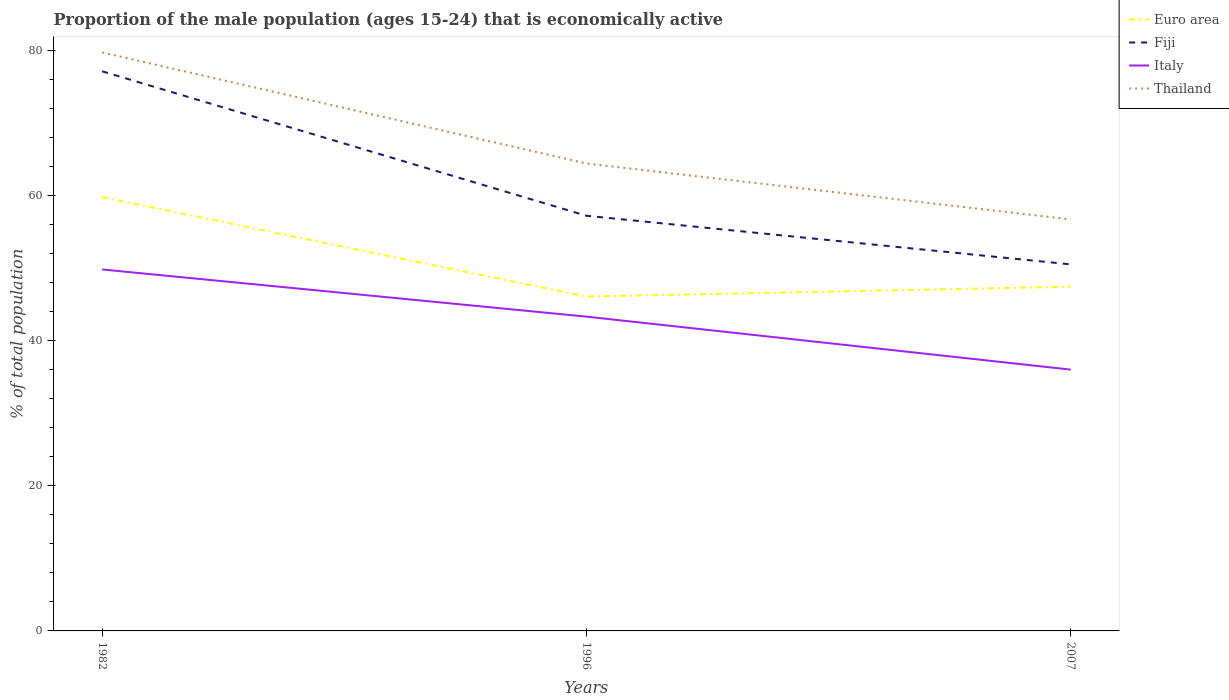How many different coloured lines are there?
Ensure brevity in your answer.  4. Does the line corresponding to Thailand intersect with the line corresponding to Fiji?
Offer a very short reply. No. Is the number of lines equal to the number of legend labels?
Your response must be concise. Yes. Across all years, what is the maximum proportion of the male population that is economically active in Euro area?
Your response must be concise. 46.06. In which year was the proportion of the male population that is economically active in Euro area maximum?
Keep it short and to the point. 1996. What is the total proportion of the male population that is economically active in Thailand in the graph?
Keep it short and to the point. 15.3. What is the difference between the highest and the second highest proportion of the male population that is economically active in Fiji?
Give a very brief answer. 26.6. What is the difference between the highest and the lowest proportion of the male population that is economically active in Italy?
Your response must be concise. 2. How many lines are there?
Your answer should be very brief. 4. What is the difference between two consecutive major ticks on the Y-axis?
Give a very brief answer. 20. Are the values on the major ticks of Y-axis written in scientific E-notation?
Your answer should be compact. No. Does the graph contain grids?
Provide a succinct answer. No. How many legend labels are there?
Ensure brevity in your answer.  4. How are the legend labels stacked?
Provide a succinct answer. Vertical. What is the title of the graph?
Offer a terse response. Proportion of the male population (ages 15-24) that is economically active. What is the label or title of the Y-axis?
Offer a terse response. % of total population. What is the % of total population of Euro area in 1982?
Make the answer very short. 59.76. What is the % of total population in Fiji in 1982?
Provide a succinct answer. 77.1. What is the % of total population in Italy in 1982?
Provide a succinct answer. 49.8. What is the % of total population in Thailand in 1982?
Provide a short and direct response. 79.7. What is the % of total population of Euro area in 1996?
Provide a succinct answer. 46.06. What is the % of total population of Fiji in 1996?
Offer a terse response. 57.2. What is the % of total population of Italy in 1996?
Your answer should be compact. 43.3. What is the % of total population of Thailand in 1996?
Your answer should be compact. 64.4. What is the % of total population in Euro area in 2007?
Make the answer very short. 47.43. What is the % of total population of Fiji in 2007?
Your response must be concise. 50.5. What is the % of total population in Italy in 2007?
Make the answer very short. 36. What is the % of total population of Thailand in 2007?
Offer a very short reply. 56.7. Across all years, what is the maximum % of total population of Euro area?
Keep it short and to the point. 59.76. Across all years, what is the maximum % of total population in Fiji?
Your answer should be compact. 77.1. Across all years, what is the maximum % of total population in Italy?
Provide a short and direct response. 49.8. Across all years, what is the maximum % of total population of Thailand?
Make the answer very short. 79.7. Across all years, what is the minimum % of total population in Euro area?
Make the answer very short. 46.06. Across all years, what is the minimum % of total population of Fiji?
Your response must be concise. 50.5. Across all years, what is the minimum % of total population of Italy?
Your answer should be compact. 36. Across all years, what is the minimum % of total population in Thailand?
Provide a succinct answer. 56.7. What is the total % of total population of Euro area in the graph?
Your response must be concise. 153.25. What is the total % of total population in Fiji in the graph?
Provide a short and direct response. 184.8. What is the total % of total population of Italy in the graph?
Ensure brevity in your answer.  129.1. What is the total % of total population of Thailand in the graph?
Ensure brevity in your answer.  200.8. What is the difference between the % of total population of Euro area in 1982 and that in 1996?
Provide a short and direct response. 13.69. What is the difference between the % of total population in Fiji in 1982 and that in 1996?
Offer a terse response. 19.9. What is the difference between the % of total population in Italy in 1982 and that in 1996?
Ensure brevity in your answer.  6.5. What is the difference between the % of total population of Euro area in 1982 and that in 2007?
Your answer should be compact. 12.33. What is the difference between the % of total population in Fiji in 1982 and that in 2007?
Give a very brief answer. 26.6. What is the difference between the % of total population of Italy in 1982 and that in 2007?
Give a very brief answer. 13.8. What is the difference between the % of total population of Thailand in 1982 and that in 2007?
Your answer should be very brief. 23. What is the difference between the % of total population in Euro area in 1996 and that in 2007?
Ensure brevity in your answer.  -1.37. What is the difference between the % of total population of Fiji in 1996 and that in 2007?
Provide a short and direct response. 6.7. What is the difference between the % of total population in Italy in 1996 and that in 2007?
Your response must be concise. 7.3. What is the difference between the % of total population in Thailand in 1996 and that in 2007?
Ensure brevity in your answer.  7.7. What is the difference between the % of total population of Euro area in 1982 and the % of total population of Fiji in 1996?
Your answer should be compact. 2.56. What is the difference between the % of total population of Euro area in 1982 and the % of total population of Italy in 1996?
Your answer should be very brief. 16.46. What is the difference between the % of total population of Euro area in 1982 and the % of total population of Thailand in 1996?
Your answer should be very brief. -4.64. What is the difference between the % of total population of Fiji in 1982 and the % of total population of Italy in 1996?
Provide a succinct answer. 33.8. What is the difference between the % of total population of Fiji in 1982 and the % of total population of Thailand in 1996?
Ensure brevity in your answer.  12.7. What is the difference between the % of total population of Italy in 1982 and the % of total population of Thailand in 1996?
Your response must be concise. -14.6. What is the difference between the % of total population of Euro area in 1982 and the % of total population of Fiji in 2007?
Ensure brevity in your answer.  9.26. What is the difference between the % of total population of Euro area in 1982 and the % of total population of Italy in 2007?
Offer a terse response. 23.76. What is the difference between the % of total population in Euro area in 1982 and the % of total population in Thailand in 2007?
Your response must be concise. 3.06. What is the difference between the % of total population of Fiji in 1982 and the % of total population of Italy in 2007?
Offer a very short reply. 41.1. What is the difference between the % of total population of Fiji in 1982 and the % of total population of Thailand in 2007?
Provide a short and direct response. 20.4. What is the difference between the % of total population in Italy in 1982 and the % of total population in Thailand in 2007?
Give a very brief answer. -6.9. What is the difference between the % of total population of Euro area in 1996 and the % of total population of Fiji in 2007?
Your answer should be very brief. -4.44. What is the difference between the % of total population in Euro area in 1996 and the % of total population in Italy in 2007?
Provide a succinct answer. 10.06. What is the difference between the % of total population of Euro area in 1996 and the % of total population of Thailand in 2007?
Make the answer very short. -10.64. What is the difference between the % of total population in Fiji in 1996 and the % of total population in Italy in 2007?
Provide a succinct answer. 21.2. What is the difference between the % of total population in Fiji in 1996 and the % of total population in Thailand in 2007?
Your answer should be compact. 0.5. What is the difference between the % of total population of Italy in 1996 and the % of total population of Thailand in 2007?
Ensure brevity in your answer.  -13.4. What is the average % of total population of Euro area per year?
Offer a very short reply. 51.08. What is the average % of total population of Fiji per year?
Provide a succinct answer. 61.6. What is the average % of total population in Italy per year?
Keep it short and to the point. 43.03. What is the average % of total population of Thailand per year?
Offer a terse response. 66.93. In the year 1982, what is the difference between the % of total population in Euro area and % of total population in Fiji?
Your response must be concise. -17.34. In the year 1982, what is the difference between the % of total population of Euro area and % of total population of Italy?
Your response must be concise. 9.96. In the year 1982, what is the difference between the % of total population in Euro area and % of total population in Thailand?
Offer a terse response. -19.94. In the year 1982, what is the difference between the % of total population in Fiji and % of total population in Italy?
Offer a very short reply. 27.3. In the year 1982, what is the difference between the % of total population in Fiji and % of total population in Thailand?
Your answer should be compact. -2.6. In the year 1982, what is the difference between the % of total population of Italy and % of total population of Thailand?
Ensure brevity in your answer.  -29.9. In the year 1996, what is the difference between the % of total population in Euro area and % of total population in Fiji?
Your answer should be very brief. -11.14. In the year 1996, what is the difference between the % of total population of Euro area and % of total population of Italy?
Provide a succinct answer. 2.76. In the year 1996, what is the difference between the % of total population in Euro area and % of total population in Thailand?
Provide a succinct answer. -18.34. In the year 1996, what is the difference between the % of total population in Fiji and % of total population in Italy?
Your answer should be compact. 13.9. In the year 1996, what is the difference between the % of total population in Fiji and % of total population in Thailand?
Provide a short and direct response. -7.2. In the year 1996, what is the difference between the % of total population of Italy and % of total population of Thailand?
Your response must be concise. -21.1. In the year 2007, what is the difference between the % of total population in Euro area and % of total population in Fiji?
Provide a short and direct response. -3.07. In the year 2007, what is the difference between the % of total population of Euro area and % of total population of Italy?
Your response must be concise. 11.43. In the year 2007, what is the difference between the % of total population in Euro area and % of total population in Thailand?
Ensure brevity in your answer.  -9.27. In the year 2007, what is the difference between the % of total population of Fiji and % of total population of Italy?
Your answer should be compact. 14.5. In the year 2007, what is the difference between the % of total population in Fiji and % of total population in Thailand?
Offer a very short reply. -6.2. In the year 2007, what is the difference between the % of total population in Italy and % of total population in Thailand?
Provide a short and direct response. -20.7. What is the ratio of the % of total population in Euro area in 1982 to that in 1996?
Provide a succinct answer. 1.3. What is the ratio of the % of total population of Fiji in 1982 to that in 1996?
Give a very brief answer. 1.35. What is the ratio of the % of total population of Italy in 1982 to that in 1996?
Keep it short and to the point. 1.15. What is the ratio of the % of total population of Thailand in 1982 to that in 1996?
Offer a terse response. 1.24. What is the ratio of the % of total population of Euro area in 1982 to that in 2007?
Offer a very short reply. 1.26. What is the ratio of the % of total population of Fiji in 1982 to that in 2007?
Make the answer very short. 1.53. What is the ratio of the % of total population of Italy in 1982 to that in 2007?
Offer a very short reply. 1.38. What is the ratio of the % of total population of Thailand in 1982 to that in 2007?
Give a very brief answer. 1.41. What is the ratio of the % of total population in Euro area in 1996 to that in 2007?
Your answer should be compact. 0.97. What is the ratio of the % of total population of Fiji in 1996 to that in 2007?
Your answer should be very brief. 1.13. What is the ratio of the % of total population of Italy in 1996 to that in 2007?
Make the answer very short. 1.2. What is the ratio of the % of total population in Thailand in 1996 to that in 2007?
Ensure brevity in your answer.  1.14. What is the difference between the highest and the second highest % of total population in Euro area?
Offer a terse response. 12.33. What is the difference between the highest and the second highest % of total population of Fiji?
Ensure brevity in your answer.  19.9. What is the difference between the highest and the lowest % of total population of Euro area?
Give a very brief answer. 13.69. What is the difference between the highest and the lowest % of total population of Fiji?
Make the answer very short. 26.6. 